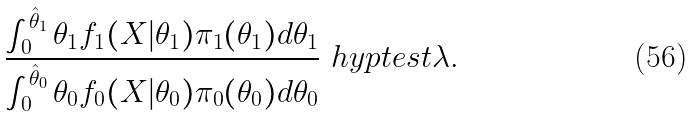<formula> <loc_0><loc_0><loc_500><loc_500>\frac { \int _ { 0 } ^ { \hat { \theta } _ { 1 } } \theta _ { 1 } f _ { 1 } ( X | \theta _ { 1 } ) \pi _ { 1 } ( \theta _ { 1 } ) d \theta _ { 1 } } { \int _ { 0 } ^ { \hat { \theta } _ { 0 } } \theta _ { 0 } f _ { 0 } ( X | \theta _ { 0 } ) \pi _ { 0 } ( \theta _ { 0 } ) d \theta _ { 0 } } \ h y p t e s t \lambda .</formula> 